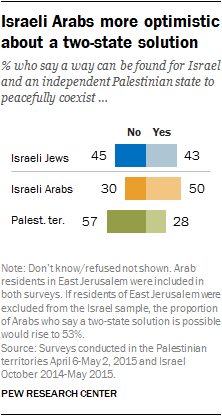Indicate a few pertinent items in this graphic. The highest value of the blue bar is 45.. The difference between 'Yes' and 'No' in total is 11. 